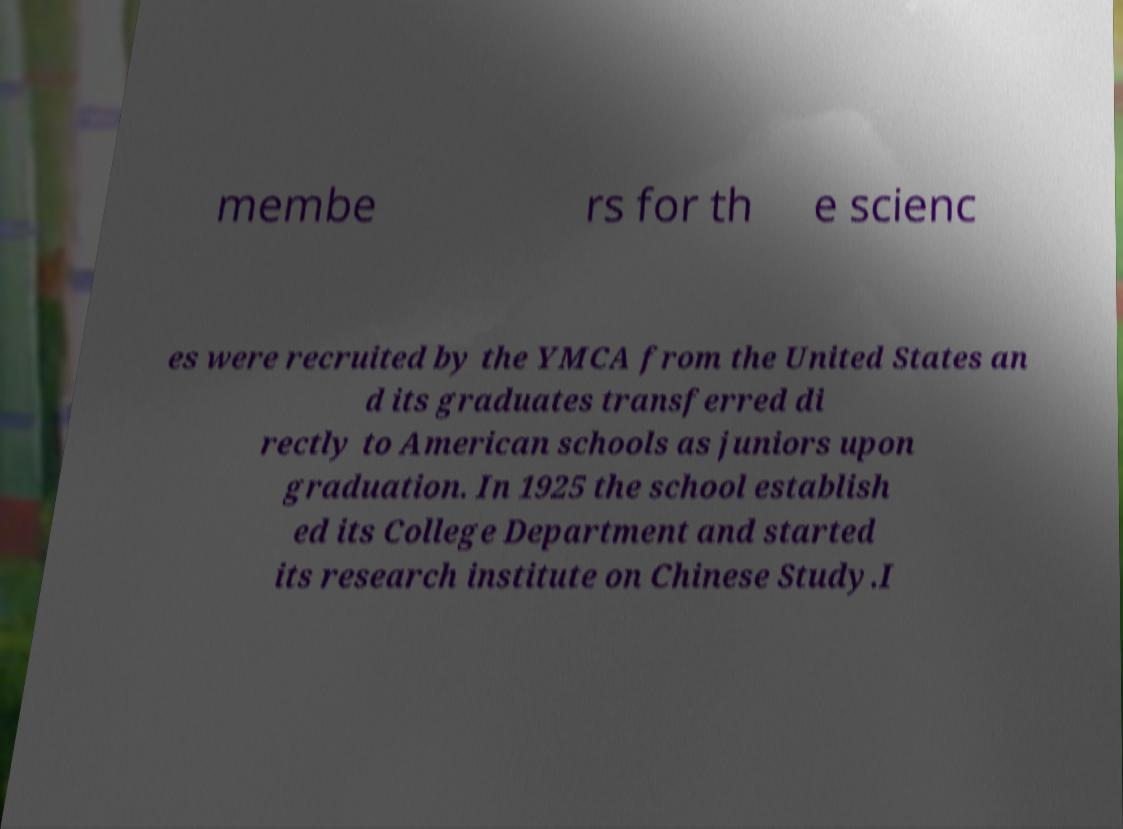Could you assist in decoding the text presented in this image and type it out clearly? membe rs for th e scienc es were recruited by the YMCA from the United States an d its graduates transferred di rectly to American schools as juniors upon graduation. In 1925 the school establish ed its College Department and started its research institute on Chinese Study.I 